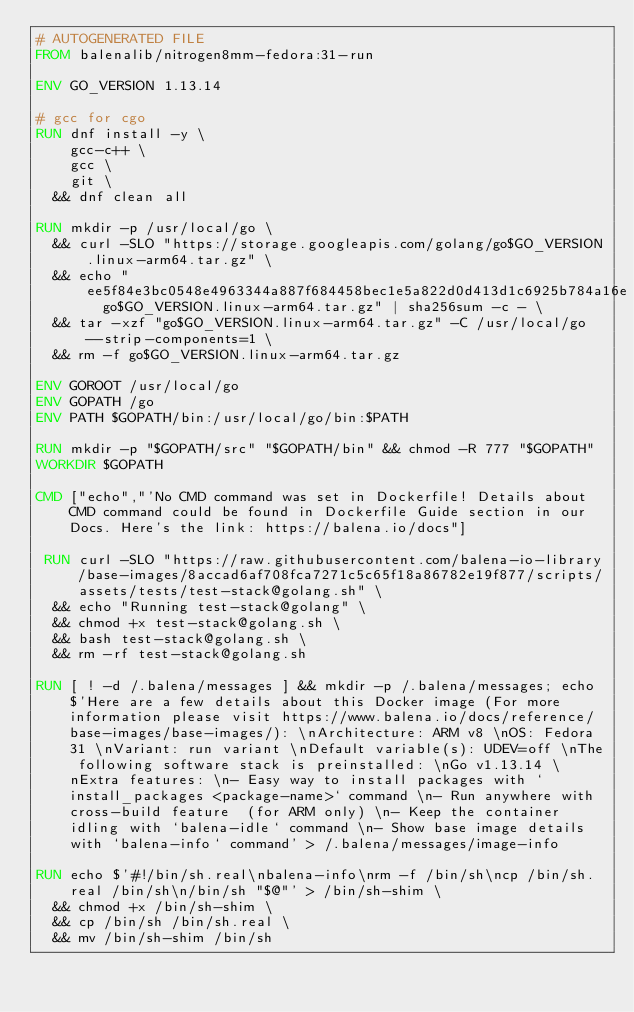<code> <loc_0><loc_0><loc_500><loc_500><_Dockerfile_># AUTOGENERATED FILE
FROM balenalib/nitrogen8mm-fedora:31-run

ENV GO_VERSION 1.13.14

# gcc for cgo
RUN dnf install -y \
		gcc-c++ \
		gcc \
		git \
	&& dnf clean all

RUN mkdir -p /usr/local/go \
	&& curl -SLO "https://storage.googleapis.com/golang/go$GO_VERSION.linux-arm64.tar.gz" \
	&& echo "ee5f84e3bc0548e4963344a887f684458bec1e5a822d0d413d1c6925b784a16e  go$GO_VERSION.linux-arm64.tar.gz" | sha256sum -c - \
	&& tar -xzf "go$GO_VERSION.linux-arm64.tar.gz" -C /usr/local/go --strip-components=1 \
	&& rm -f go$GO_VERSION.linux-arm64.tar.gz

ENV GOROOT /usr/local/go
ENV GOPATH /go
ENV PATH $GOPATH/bin:/usr/local/go/bin:$PATH

RUN mkdir -p "$GOPATH/src" "$GOPATH/bin" && chmod -R 777 "$GOPATH"
WORKDIR $GOPATH

CMD ["echo","'No CMD command was set in Dockerfile! Details about CMD command could be found in Dockerfile Guide section in our Docs. Here's the link: https://balena.io/docs"]

 RUN curl -SLO "https://raw.githubusercontent.com/balena-io-library/base-images/8accad6af708fca7271c5c65f18a86782e19f877/scripts/assets/tests/test-stack@golang.sh" \
  && echo "Running test-stack@golang" \
  && chmod +x test-stack@golang.sh \
  && bash test-stack@golang.sh \
  && rm -rf test-stack@golang.sh 

RUN [ ! -d /.balena/messages ] && mkdir -p /.balena/messages; echo $'Here are a few details about this Docker image (For more information please visit https://www.balena.io/docs/reference/base-images/base-images/): \nArchitecture: ARM v8 \nOS: Fedora 31 \nVariant: run variant \nDefault variable(s): UDEV=off \nThe following software stack is preinstalled: \nGo v1.13.14 \nExtra features: \n- Easy way to install packages with `install_packages <package-name>` command \n- Run anywhere with cross-build feature  (for ARM only) \n- Keep the container idling with `balena-idle` command \n- Show base image details with `balena-info` command' > /.balena/messages/image-info

RUN echo $'#!/bin/sh.real\nbalena-info\nrm -f /bin/sh\ncp /bin/sh.real /bin/sh\n/bin/sh "$@"' > /bin/sh-shim \
	&& chmod +x /bin/sh-shim \
	&& cp /bin/sh /bin/sh.real \
	&& mv /bin/sh-shim /bin/sh</code> 